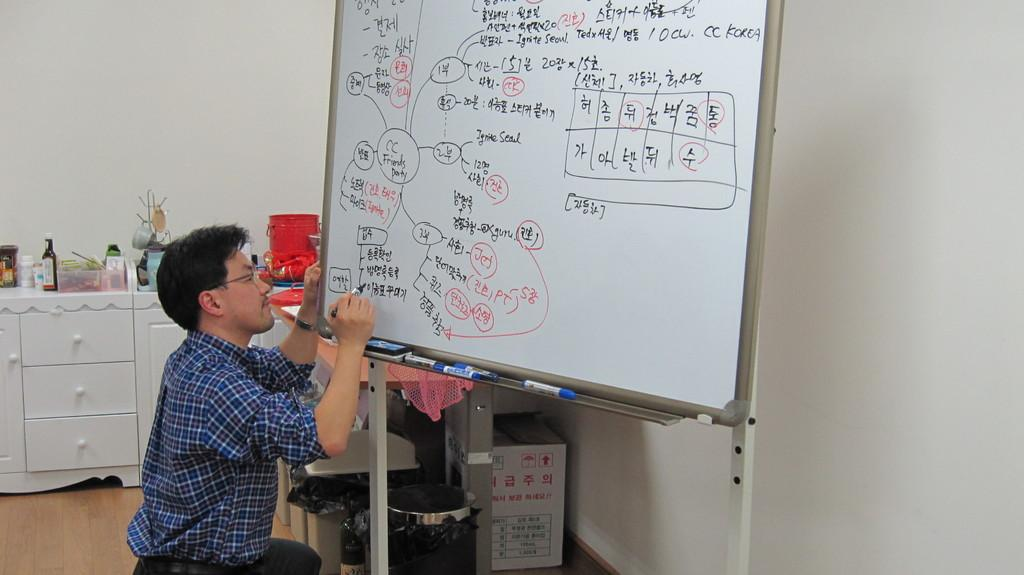Provide a one-sentence caption for the provided image. Person writing on a whiteboard that says korean words on it. 